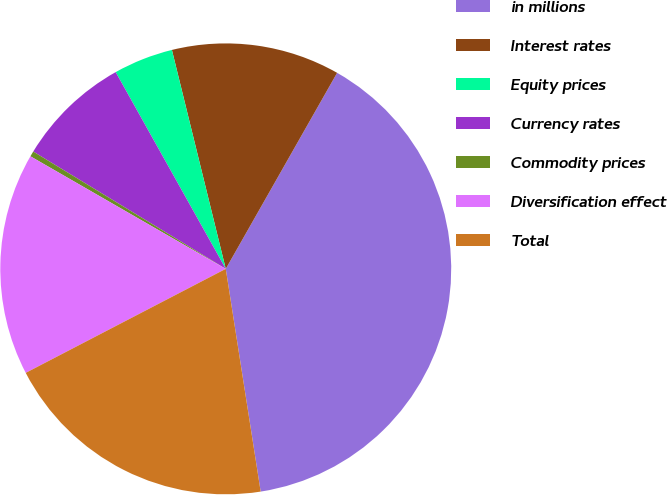Convert chart to OTSL. <chart><loc_0><loc_0><loc_500><loc_500><pie_chart><fcel>in millions<fcel>Interest rates<fcel>Equity prices<fcel>Currency rates<fcel>Commodity prices<fcel>Diversification effect<fcel>Total<nl><fcel>39.3%<fcel>12.06%<fcel>4.28%<fcel>8.17%<fcel>0.39%<fcel>15.95%<fcel>19.84%<nl></chart> 